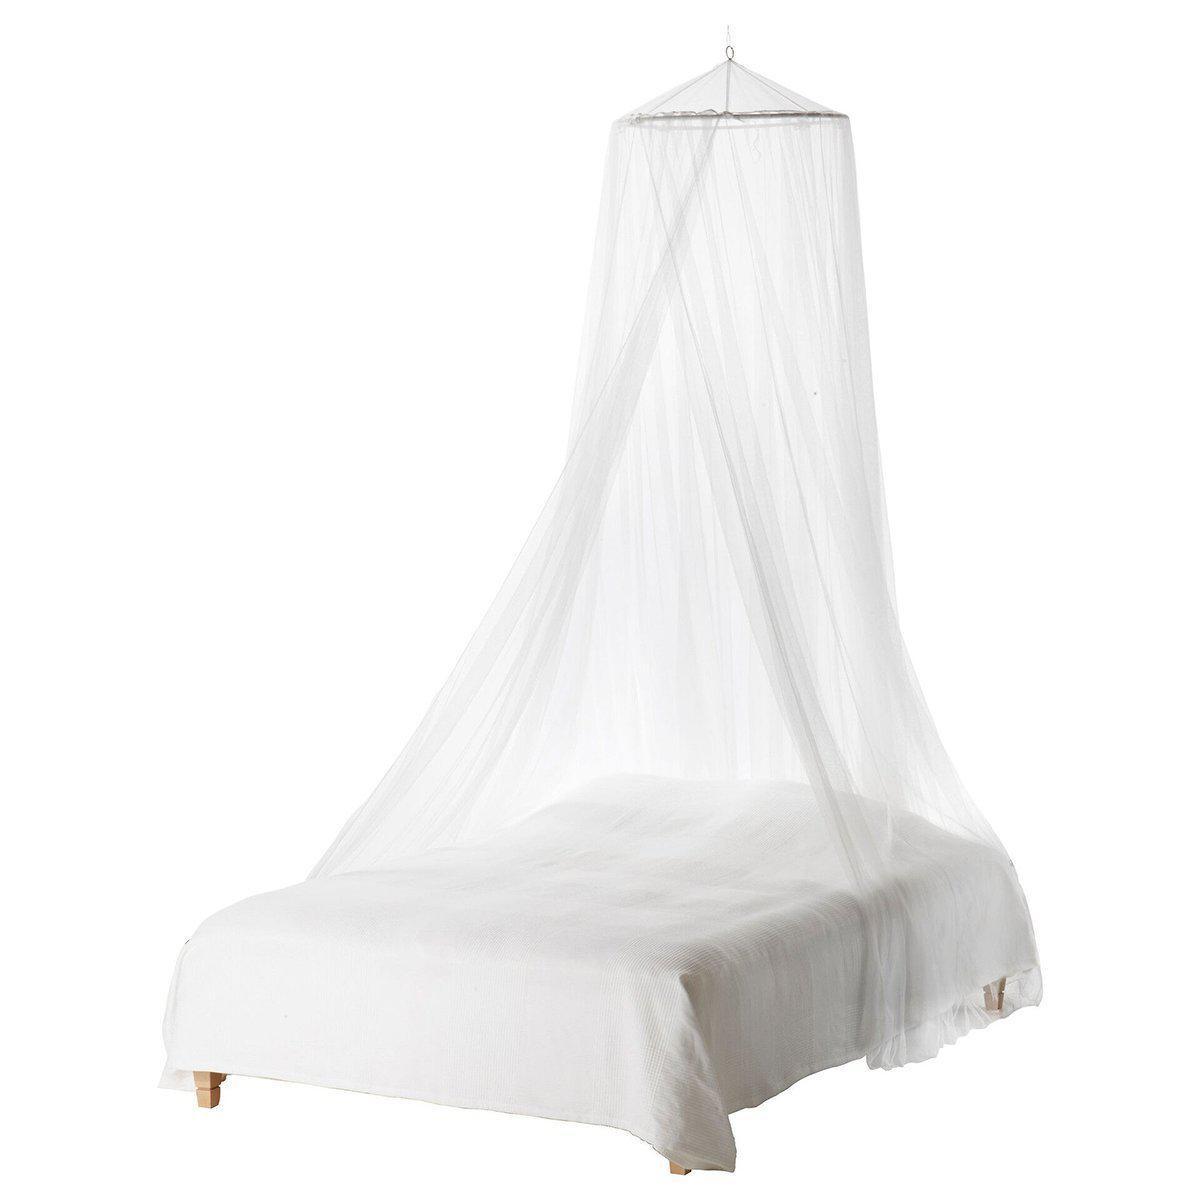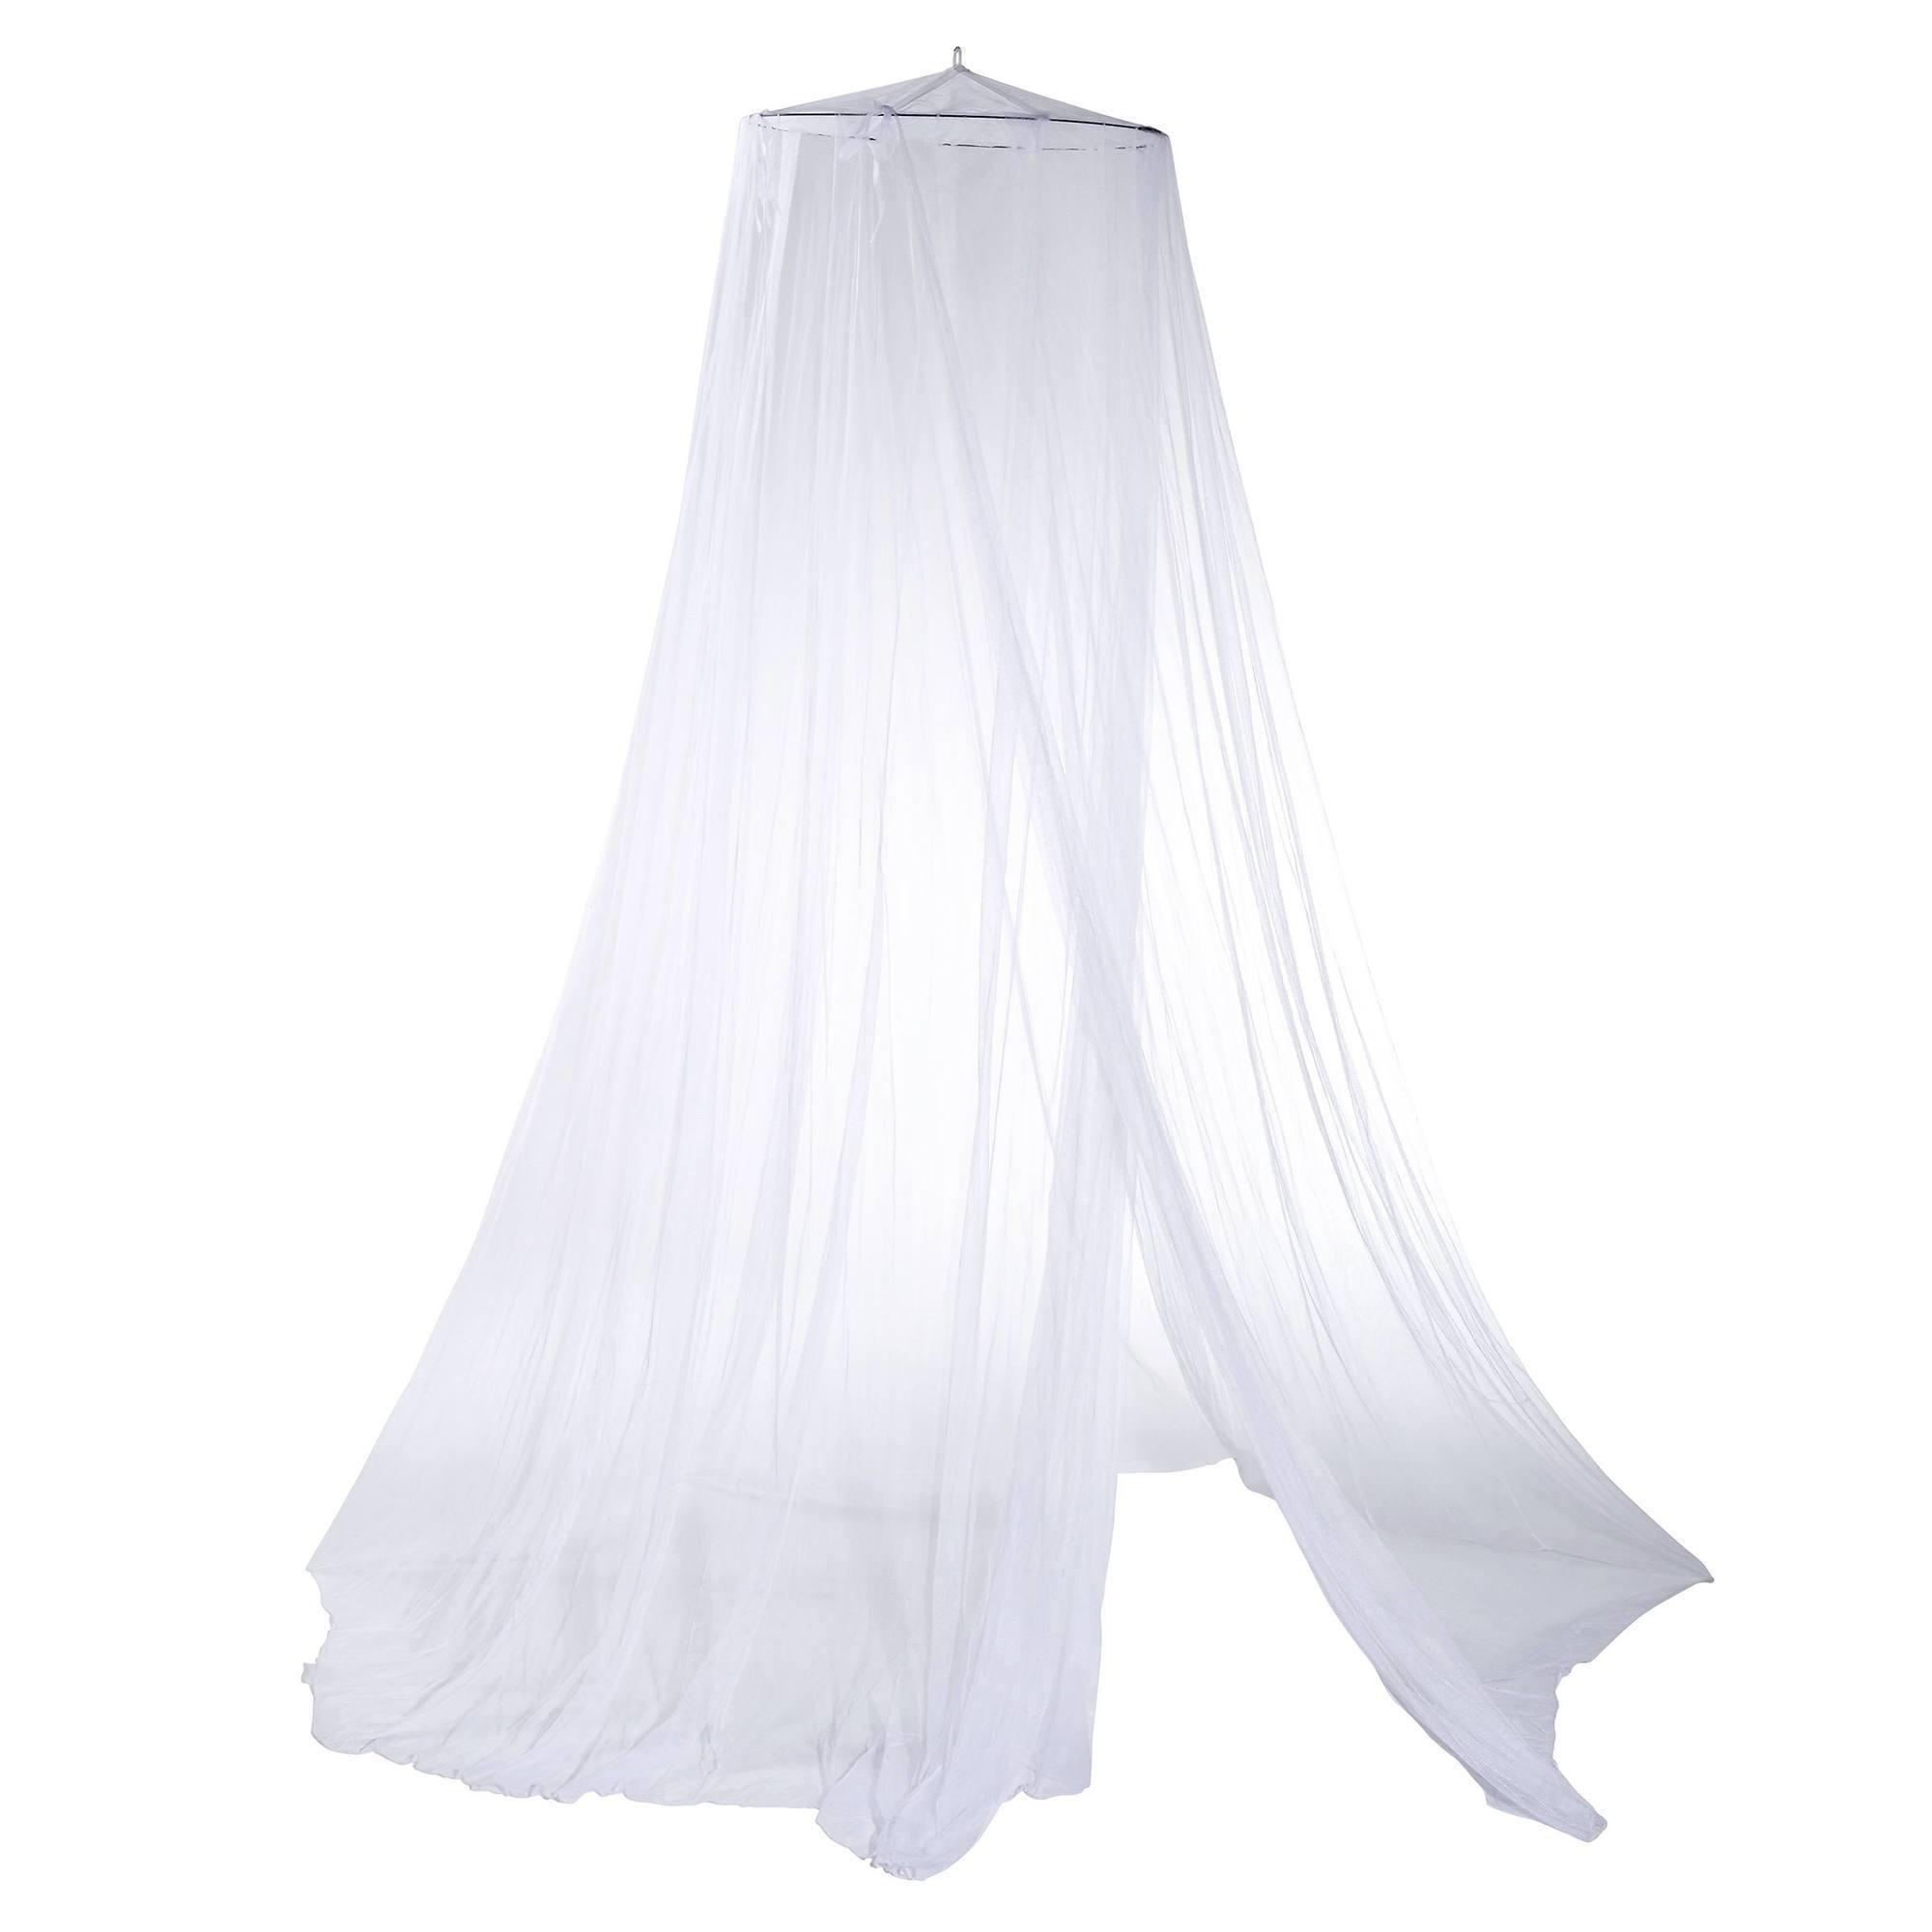The first image is the image on the left, the second image is the image on the right. For the images displayed, is the sentence "Each image shows a gauzy white canopy that drapes from a cone shape suspended from the ceiling, but only the left image shows a canopy over a bed." factually correct? Answer yes or no. Yes. The first image is the image on the left, the second image is the image on the right. For the images displayed, is the sentence "There is at least one window behind the canopy in one of the images" factually correct? Answer yes or no. No. 